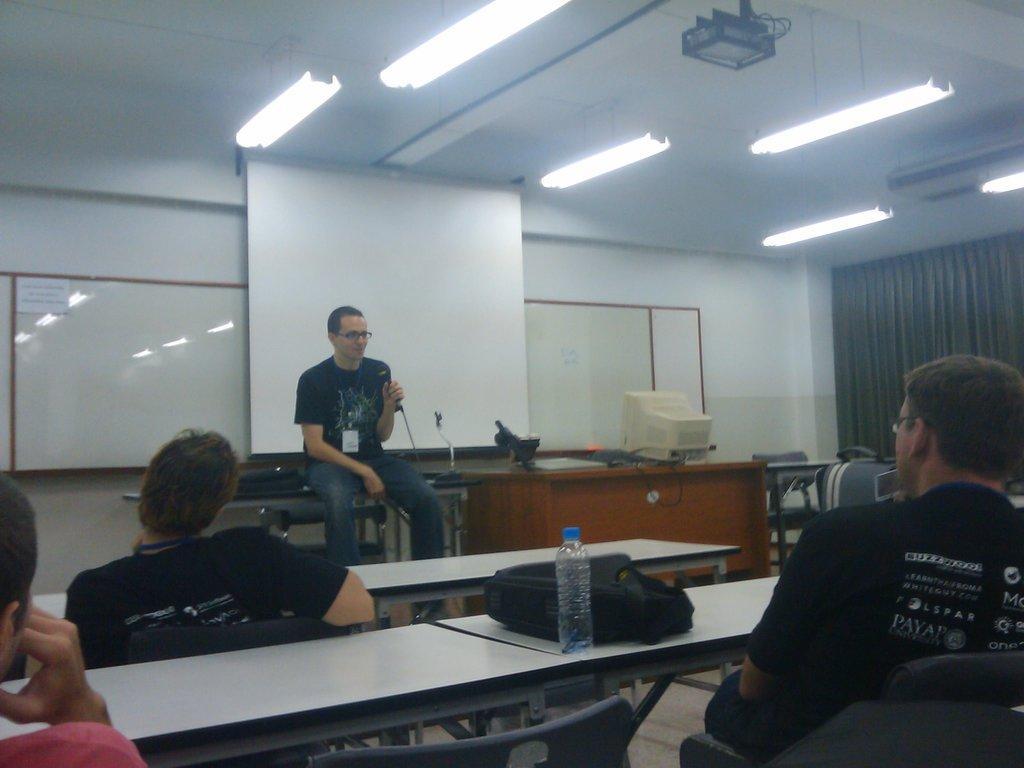Can you describe this image briefly? In this image i can see few persons sitting on chairs in front of desks, On the desk can see a bottle and a bag. In the background i can see a person sitting on the table and holding a microphone. I can see a table on which there is a monitor and a projection screen ,a projector,the ceiling, few lights, a curtain and the wall in the background. 